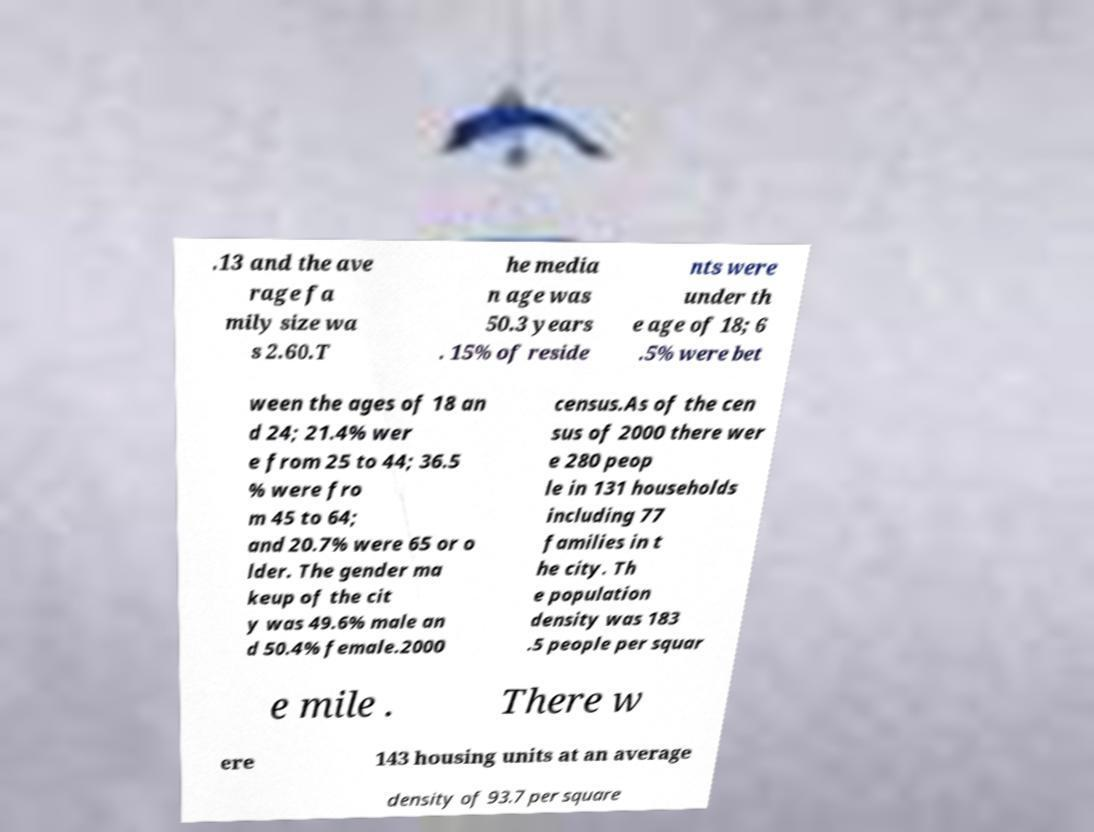For documentation purposes, I need the text within this image transcribed. Could you provide that? .13 and the ave rage fa mily size wa s 2.60.T he media n age was 50.3 years . 15% of reside nts were under th e age of 18; 6 .5% were bet ween the ages of 18 an d 24; 21.4% wer e from 25 to 44; 36.5 % were fro m 45 to 64; and 20.7% were 65 or o lder. The gender ma keup of the cit y was 49.6% male an d 50.4% female.2000 census.As of the cen sus of 2000 there wer e 280 peop le in 131 households including 77 families in t he city. Th e population density was 183 .5 people per squar e mile . There w ere 143 housing units at an average density of 93.7 per square 